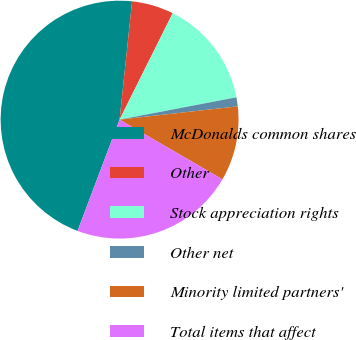Convert chart to OTSL. <chart><loc_0><loc_0><loc_500><loc_500><pie_chart><fcel>McDonalds common shares<fcel>Other<fcel>Stock appreciation rights<fcel>Other net<fcel>Minority limited partners'<fcel>Total items that affect<nl><fcel>45.93%<fcel>5.69%<fcel>14.63%<fcel>1.22%<fcel>10.16%<fcel>22.37%<nl></chart> 